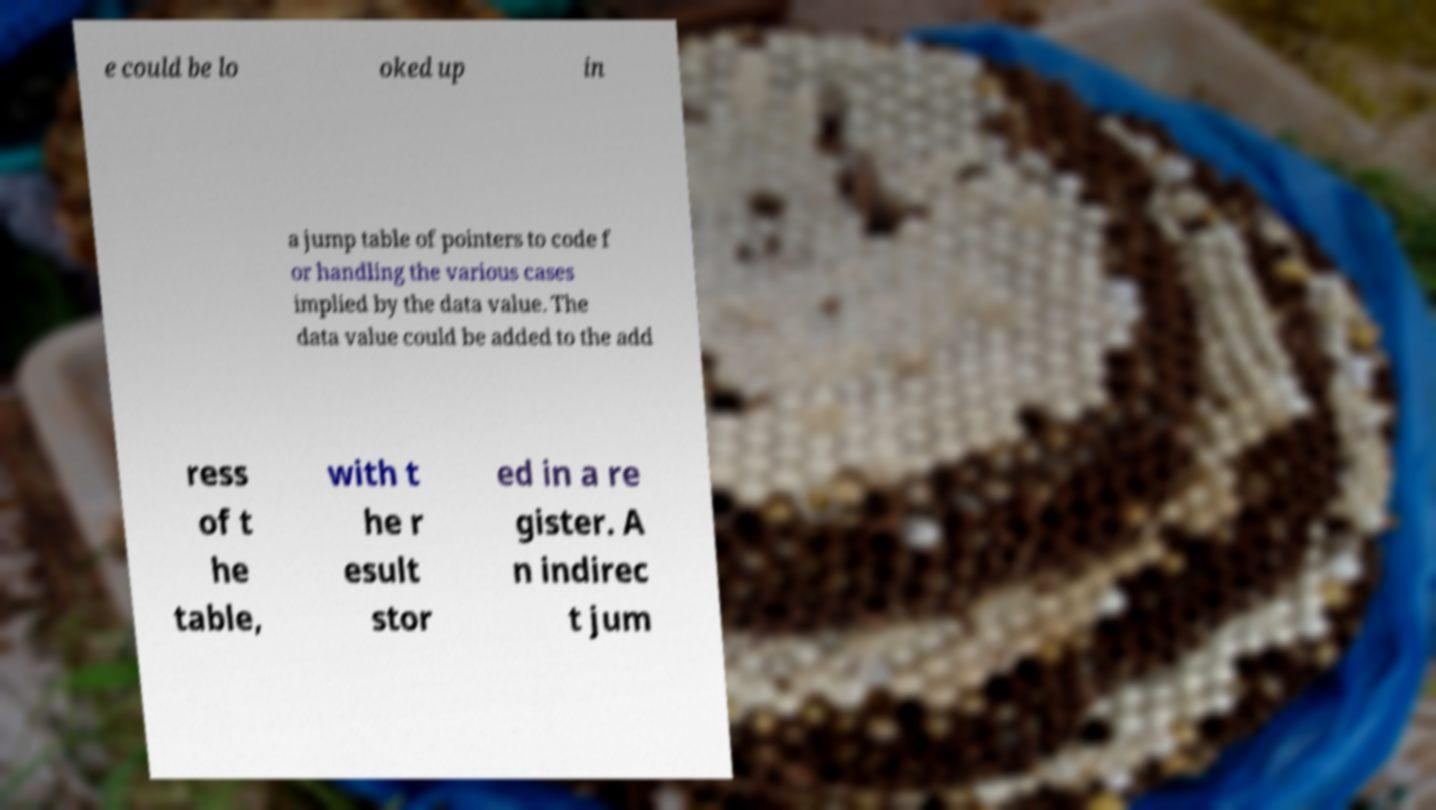Can you accurately transcribe the text from the provided image for me? e could be lo oked up in a jump table of pointers to code f or handling the various cases implied by the data value. The data value could be added to the add ress of t he table, with t he r esult stor ed in a re gister. A n indirec t jum 